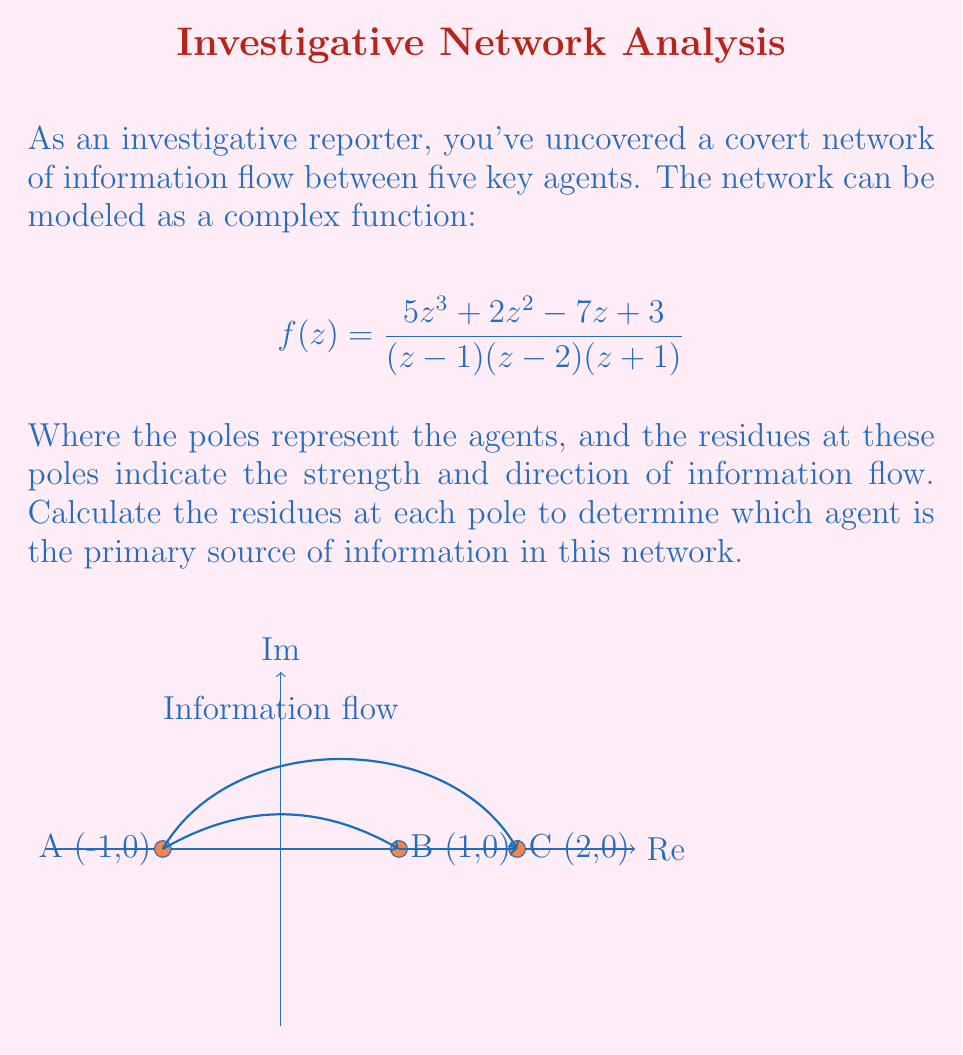Give your solution to this math problem. To solve this problem, we need to calculate the residues at each pole of the function. The poles are at $z=-1$, $z=1$, and $z=2$.

1) First, let's factor the numerator:
   $$f(z) = \frac{5z^3 + 2z^2 - 7z + 3}{(z-1)(z-2)(z+1)}$$

2) For simple poles, we can use the formula:
   $$\text{Res}(f,a) = \lim_{z \to a} (z-a)f(z)$$

3) For $z=-1$:
   $$\text{Res}(f,-1) = \lim_{z \to -1} (z+1)\frac{5z^3 + 2z^2 - 7z + 3}{(z-1)(z-2)(z+1)}$$
   $$= \lim_{z \to -1} \frac{5z^3 + 2z^2 - 7z + 3}{(z-1)(z-2)}$$
   $$= \frac{5(-1)^3 + 2(-1)^2 - 7(-1) + 3}{(-1-1)(-1-2)} = \frac{-5+2+7+3}{6} = \frac{7}{6}$$

4) For $z=1$:
   $$\text{Res}(f,1) = \lim_{z \to 1} (z-1)\frac{5z^3 + 2z^2 - 7z + 3}{(z-1)(z-2)(z+1)}$$
   $$= \lim_{z \to 1} \frac{5z^3 + 2z^2 - 7z + 3}{(z-2)(z+1)}$$
   $$= \frac{5(1)^3 + 2(1)^2 - 7(1) + 3}{(1-2)(1+1)} = \frac{5+2-7+3}{-2} = \frac{3}{2}$$

5) For $z=2$:
   $$\text{Res}(f,2) = \lim_{z \to 2} (z-2)\frac{5z^3 + 2z^2 - 7z + 3}{(z-1)(z-2)(z+1)}$$
   $$= \lim_{z \to 2} \frac{5z^3 + 2z^2 - 7z + 3}{(z-1)(z+1)}$$
   $$= \frac{5(2)^3 + 2(2)^2 - 7(2) + 3}{(2-1)(2+1)} = \frac{40+8-14+3}{3} = \frac{37}{3}$$

6) Comparing the magnitudes of the residues:
   $|\text{Res}(f,-1)| = |\frac{7}{6}| \approx 1.17$
   $|\text{Res}(f,1)| = |\frac{3}{2}| = 1.5$
   $|\text{Res}(f,2)| = |\frac{37}{3}| \approx 12.33$

The largest residue in magnitude corresponds to the agent at $z=2$, indicating this agent is the primary source of information in the network.
Answer: Agent C (at $z=2$) with residue $\frac{37}{3}$ is the primary source. 